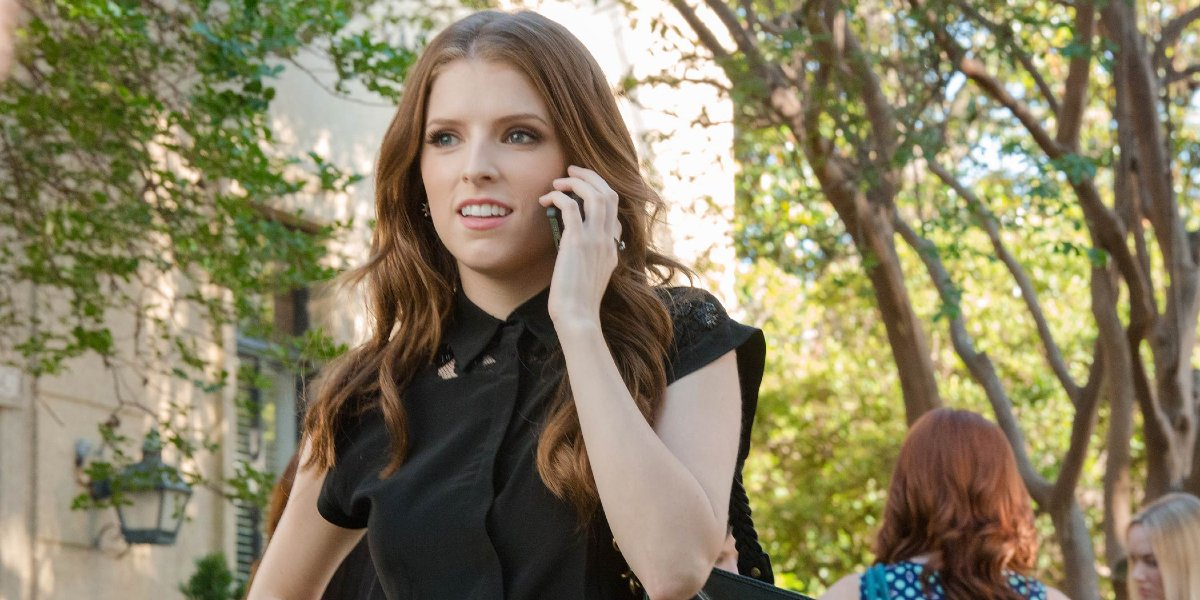Imagine an out-of-this-world scenario that she could be part of in this setting. In an out-of-this-world scenario, she could secretly be a member of an elite group of undercover time travelers. The phone she’s talking into is actually a sophisticated device that allows her to communicate across different time periods. As she walks down this seemingly ordinary street, she might be receiving crucial information about an upcoming mission to alter an event in the past. The trees around her actually contain hidden gateways to different eras, and her casual stroll is part of an elaborate camouflage to keep her identity hidden from those who might disrupt the timeline. What would be her next move in this sci-fi thriller setting? In this sci-fi thriller setting, her next move would be to enter one of the concealed gateways among the trees. She would continue her conversation, gathering the final pieces of intel required to execute her mission flawlessly. As she walks, the camera might cut to a close-up of her device, showcasing holographic displays of different centuries and pivotal events. She might then step through an invisible portal, seamlessly transitioning from the tree-lined street to a historical battleground or a futuristic city, ready to subtly influence history to ensure the future unfolds as intended. 